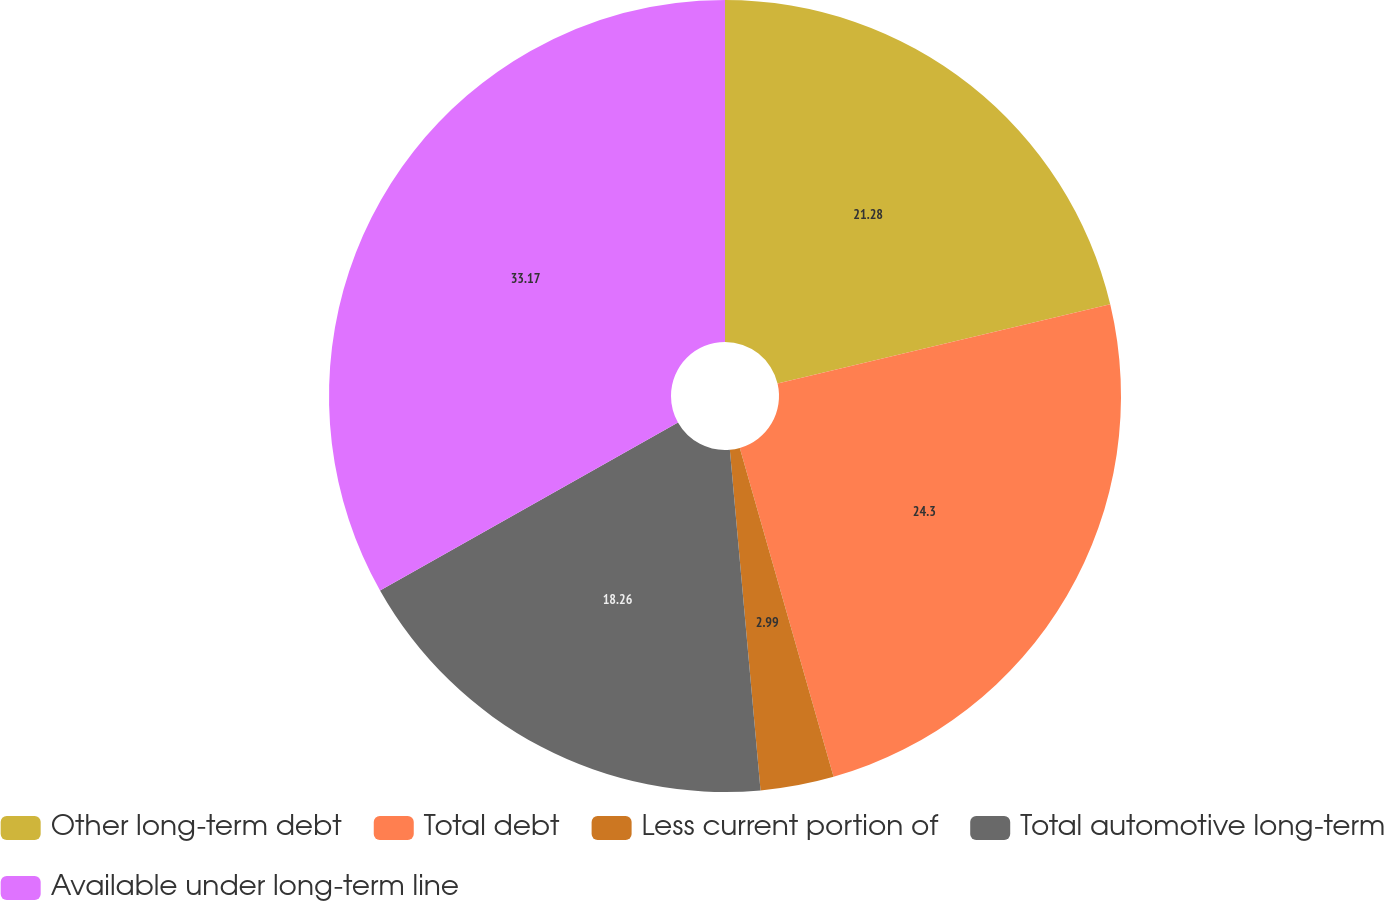Convert chart. <chart><loc_0><loc_0><loc_500><loc_500><pie_chart><fcel>Other long-term debt<fcel>Total debt<fcel>Less current portion of<fcel>Total automotive long-term<fcel>Available under long-term line<nl><fcel>21.28%<fcel>24.3%<fcel>2.99%<fcel>18.26%<fcel>33.17%<nl></chart> 